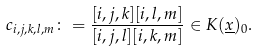<formula> <loc_0><loc_0><loc_500><loc_500>c _ { i , j , k , l , m } \colon = \frac { [ i , j , k ] [ i , l , m ] } { [ i , j , l ] [ i , k , m ] } \in K ( \underline { x } ) _ { 0 } .</formula> 